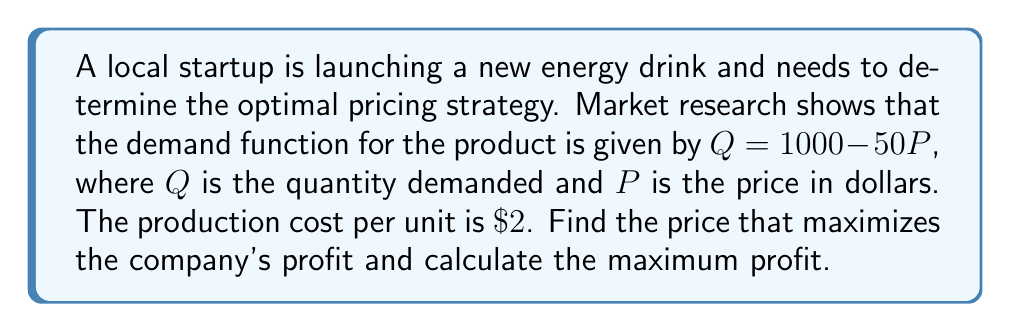Help me with this question. To solve this problem, we'll follow these steps:

1) First, let's define the profit function. Profit is revenue minus cost:
   $\text{Profit} = \text{Revenue} - \text{Cost}$

2) Revenue is price times quantity: $R = PQ$
   Cost is the per-unit cost times quantity plus any fixed costs: $C = 2Q$ (assuming no fixed costs)

3) Substituting the demand function $Q = 1000 - 50P$ into these equations:
   $R = P(1000 - 50P) = 1000P - 50P^2$
   $C = 2(1000 - 50P) = 2000 - 100P$

4) Now we can write the profit function:
   $\text{Profit} = R - C = (1000P - 50P^2) - (2000 - 100P)$
   $\text{Profit} = 1000P - 50P^2 - 2000 + 100P$
   $\text{Profit} = 1100P - 50P^2 - 2000$

5) To find the maximum profit, we need to find where the derivative of the profit function equals zero:
   $\frac{d(\text{Profit})}{dP} = 1100 - 100P$

6) Set this equal to zero and solve for P:
   $1100 - 100P = 0$
   $100P = 1100$
   $P = 11$

7) To confirm this is a maximum (not a minimum), we can check the second derivative:
   $\frac{d^2(\text{Profit})}{dP^2} = -100$, which is negative, confirming a maximum.

8) Calculate the maximum profit by plugging $P = 11$ back into the profit function:
   $\text{Profit} = 1100(11) - 50(11)^2 - 2000$
   $= 12100 - 6050 - 2000 = 4050$

Therefore, the optimal price is $\$11$ and the maximum profit is $\$4050$.
Answer: The optimal price is $\$11$ and the maximum profit is $\$4050$. 